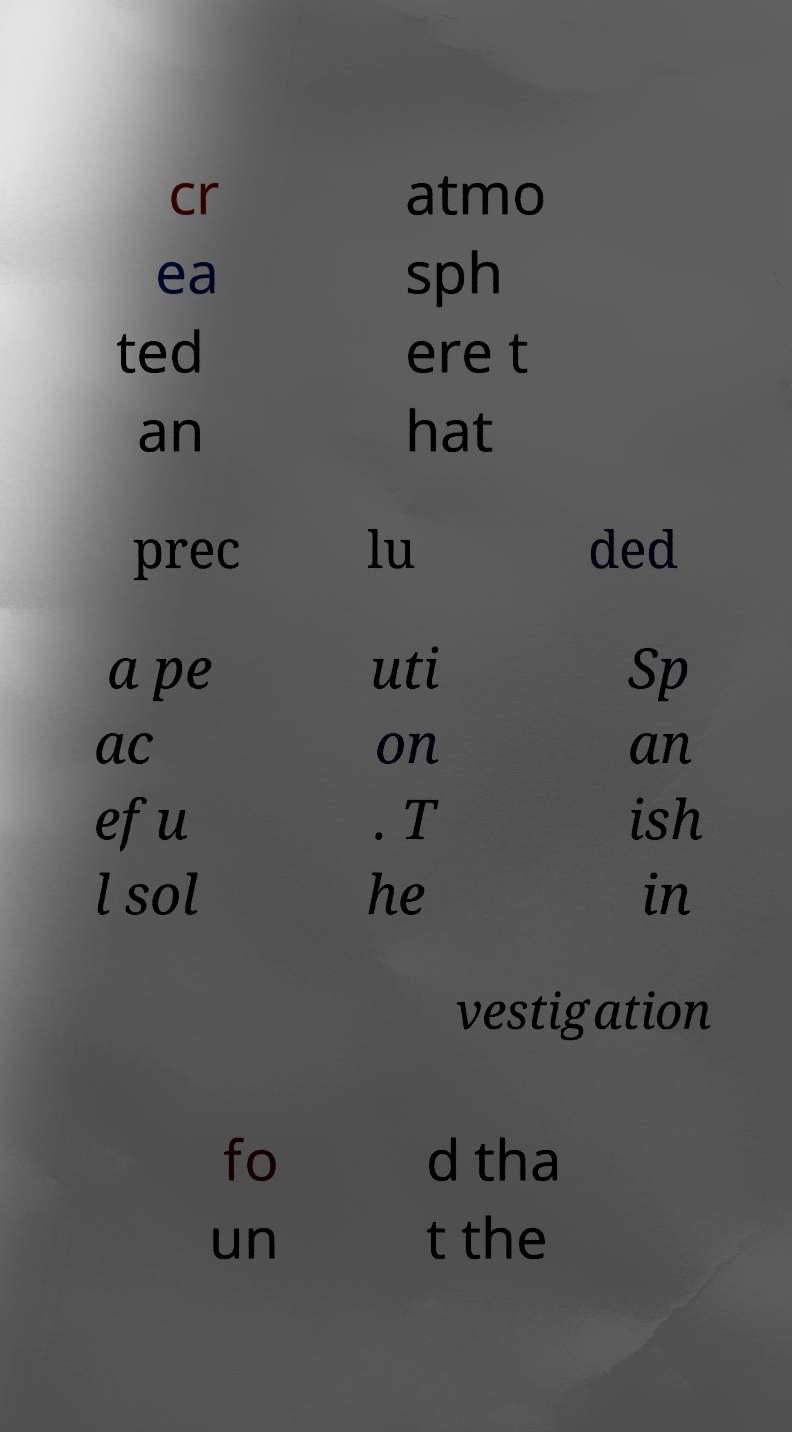Please identify and transcribe the text found in this image. cr ea ted an atmo sph ere t hat prec lu ded a pe ac efu l sol uti on . T he Sp an ish in vestigation fo un d tha t the 